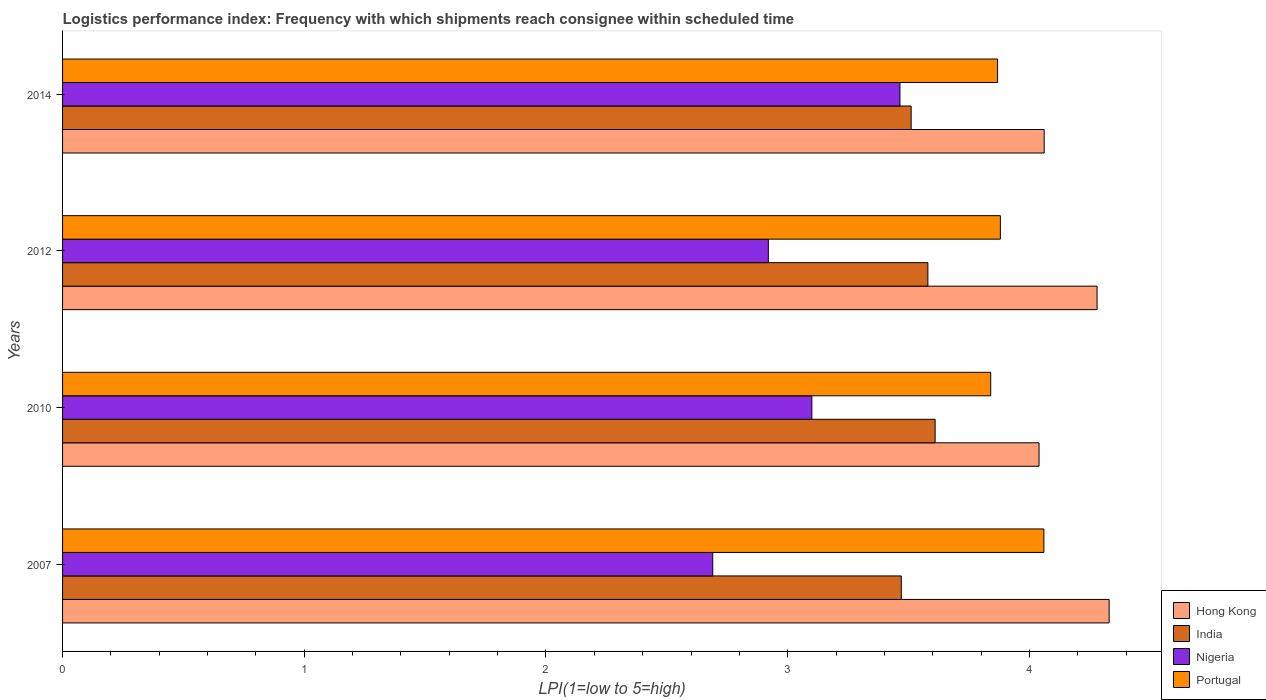How many different coloured bars are there?
Keep it short and to the point. 4. How many groups of bars are there?
Provide a succinct answer. 4. Are the number of bars per tick equal to the number of legend labels?
Provide a short and direct response. Yes. Are the number of bars on each tick of the Y-axis equal?
Give a very brief answer. Yes. How many bars are there on the 3rd tick from the bottom?
Give a very brief answer. 4. What is the label of the 3rd group of bars from the top?
Your response must be concise. 2010. What is the logistics performance index in Nigeria in 2012?
Ensure brevity in your answer.  2.92. Across all years, what is the maximum logistics performance index in India?
Your response must be concise. 3.61. Across all years, what is the minimum logistics performance index in Nigeria?
Your answer should be compact. 2.69. What is the total logistics performance index in Portugal in the graph?
Keep it short and to the point. 15.65. What is the difference between the logistics performance index in Portugal in 2007 and that in 2010?
Give a very brief answer. 0.22. What is the difference between the logistics performance index in Portugal in 2014 and the logistics performance index in Nigeria in 2012?
Provide a succinct answer. 0.95. What is the average logistics performance index in Nigeria per year?
Offer a very short reply. 3.04. In the year 2007, what is the difference between the logistics performance index in India and logistics performance index in Hong Kong?
Make the answer very short. -0.86. In how many years, is the logistics performance index in Hong Kong greater than 3 ?
Provide a succinct answer. 4. What is the ratio of the logistics performance index in India in 2007 to that in 2010?
Your answer should be compact. 0.96. What is the difference between the highest and the second highest logistics performance index in India?
Give a very brief answer. 0.03. What is the difference between the highest and the lowest logistics performance index in Nigeria?
Provide a short and direct response. 0.77. Is the sum of the logistics performance index in Portugal in 2007 and 2012 greater than the maximum logistics performance index in Nigeria across all years?
Give a very brief answer. Yes. What does the 4th bar from the top in 2012 represents?
Offer a very short reply. Hong Kong. What does the 2nd bar from the bottom in 2014 represents?
Make the answer very short. India. Is it the case that in every year, the sum of the logistics performance index in Hong Kong and logistics performance index in Portugal is greater than the logistics performance index in Nigeria?
Provide a succinct answer. Yes. How many bars are there?
Provide a short and direct response. 16. How many years are there in the graph?
Provide a succinct answer. 4. Are the values on the major ticks of X-axis written in scientific E-notation?
Ensure brevity in your answer.  No. Does the graph contain grids?
Provide a short and direct response. No. Where does the legend appear in the graph?
Ensure brevity in your answer.  Bottom right. How are the legend labels stacked?
Make the answer very short. Vertical. What is the title of the graph?
Ensure brevity in your answer.  Logistics performance index: Frequency with which shipments reach consignee within scheduled time. What is the label or title of the X-axis?
Offer a terse response. LPI(1=low to 5=high). What is the label or title of the Y-axis?
Ensure brevity in your answer.  Years. What is the LPI(1=low to 5=high) of Hong Kong in 2007?
Offer a very short reply. 4.33. What is the LPI(1=low to 5=high) in India in 2007?
Offer a very short reply. 3.47. What is the LPI(1=low to 5=high) in Nigeria in 2007?
Offer a terse response. 2.69. What is the LPI(1=low to 5=high) of Portugal in 2007?
Make the answer very short. 4.06. What is the LPI(1=low to 5=high) in Hong Kong in 2010?
Give a very brief answer. 4.04. What is the LPI(1=low to 5=high) of India in 2010?
Offer a terse response. 3.61. What is the LPI(1=low to 5=high) in Nigeria in 2010?
Your response must be concise. 3.1. What is the LPI(1=low to 5=high) of Portugal in 2010?
Provide a short and direct response. 3.84. What is the LPI(1=low to 5=high) of Hong Kong in 2012?
Offer a very short reply. 4.28. What is the LPI(1=low to 5=high) of India in 2012?
Offer a terse response. 3.58. What is the LPI(1=low to 5=high) of Nigeria in 2012?
Provide a short and direct response. 2.92. What is the LPI(1=low to 5=high) in Portugal in 2012?
Your answer should be very brief. 3.88. What is the LPI(1=low to 5=high) of Hong Kong in 2014?
Give a very brief answer. 4.06. What is the LPI(1=low to 5=high) in India in 2014?
Your answer should be compact. 3.51. What is the LPI(1=low to 5=high) in Nigeria in 2014?
Keep it short and to the point. 3.46. What is the LPI(1=low to 5=high) in Portugal in 2014?
Provide a succinct answer. 3.87. Across all years, what is the maximum LPI(1=low to 5=high) of Hong Kong?
Offer a very short reply. 4.33. Across all years, what is the maximum LPI(1=low to 5=high) of India?
Keep it short and to the point. 3.61. Across all years, what is the maximum LPI(1=low to 5=high) in Nigeria?
Your response must be concise. 3.46. Across all years, what is the maximum LPI(1=low to 5=high) of Portugal?
Keep it short and to the point. 4.06. Across all years, what is the minimum LPI(1=low to 5=high) of Hong Kong?
Your response must be concise. 4.04. Across all years, what is the minimum LPI(1=low to 5=high) in India?
Give a very brief answer. 3.47. Across all years, what is the minimum LPI(1=low to 5=high) in Nigeria?
Make the answer very short. 2.69. Across all years, what is the minimum LPI(1=low to 5=high) in Portugal?
Offer a very short reply. 3.84. What is the total LPI(1=low to 5=high) in Hong Kong in the graph?
Make the answer very short. 16.71. What is the total LPI(1=low to 5=high) in India in the graph?
Offer a terse response. 14.17. What is the total LPI(1=low to 5=high) in Nigeria in the graph?
Your answer should be very brief. 12.17. What is the total LPI(1=low to 5=high) in Portugal in the graph?
Offer a terse response. 15.65. What is the difference between the LPI(1=low to 5=high) of Hong Kong in 2007 and that in 2010?
Offer a very short reply. 0.29. What is the difference between the LPI(1=low to 5=high) of India in 2007 and that in 2010?
Ensure brevity in your answer.  -0.14. What is the difference between the LPI(1=low to 5=high) in Nigeria in 2007 and that in 2010?
Your response must be concise. -0.41. What is the difference between the LPI(1=low to 5=high) in Portugal in 2007 and that in 2010?
Your response must be concise. 0.22. What is the difference between the LPI(1=low to 5=high) of Hong Kong in 2007 and that in 2012?
Give a very brief answer. 0.05. What is the difference between the LPI(1=low to 5=high) of India in 2007 and that in 2012?
Keep it short and to the point. -0.11. What is the difference between the LPI(1=low to 5=high) of Nigeria in 2007 and that in 2012?
Keep it short and to the point. -0.23. What is the difference between the LPI(1=low to 5=high) of Portugal in 2007 and that in 2012?
Keep it short and to the point. 0.18. What is the difference between the LPI(1=low to 5=high) of Hong Kong in 2007 and that in 2014?
Your answer should be very brief. 0.27. What is the difference between the LPI(1=low to 5=high) in India in 2007 and that in 2014?
Your answer should be very brief. -0.04. What is the difference between the LPI(1=low to 5=high) of Nigeria in 2007 and that in 2014?
Provide a succinct answer. -0.77. What is the difference between the LPI(1=low to 5=high) of Portugal in 2007 and that in 2014?
Offer a very short reply. 0.19. What is the difference between the LPI(1=low to 5=high) in Hong Kong in 2010 and that in 2012?
Keep it short and to the point. -0.24. What is the difference between the LPI(1=low to 5=high) in India in 2010 and that in 2012?
Keep it short and to the point. 0.03. What is the difference between the LPI(1=low to 5=high) of Nigeria in 2010 and that in 2012?
Keep it short and to the point. 0.18. What is the difference between the LPI(1=low to 5=high) of Portugal in 2010 and that in 2012?
Provide a succinct answer. -0.04. What is the difference between the LPI(1=low to 5=high) of Hong Kong in 2010 and that in 2014?
Offer a terse response. -0.02. What is the difference between the LPI(1=low to 5=high) of India in 2010 and that in 2014?
Ensure brevity in your answer.  0.1. What is the difference between the LPI(1=low to 5=high) of Nigeria in 2010 and that in 2014?
Your answer should be compact. -0.36. What is the difference between the LPI(1=low to 5=high) of Portugal in 2010 and that in 2014?
Ensure brevity in your answer.  -0.03. What is the difference between the LPI(1=low to 5=high) of Hong Kong in 2012 and that in 2014?
Ensure brevity in your answer.  0.22. What is the difference between the LPI(1=low to 5=high) of India in 2012 and that in 2014?
Your answer should be very brief. 0.07. What is the difference between the LPI(1=low to 5=high) of Nigeria in 2012 and that in 2014?
Provide a short and direct response. -0.54. What is the difference between the LPI(1=low to 5=high) of Portugal in 2012 and that in 2014?
Ensure brevity in your answer.  0.01. What is the difference between the LPI(1=low to 5=high) of Hong Kong in 2007 and the LPI(1=low to 5=high) of India in 2010?
Your answer should be compact. 0.72. What is the difference between the LPI(1=low to 5=high) of Hong Kong in 2007 and the LPI(1=low to 5=high) of Nigeria in 2010?
Offer a terse response. 1.23. What is the difference between the LPI(1=low to 5=high) of Hong Kong in 2007 and the LPI(1=low to 5=high) of Portugal in 2010?
Your answer should be very brief. 0.49. What is the difference between the LPI(1=low to 5=high) of India in 2007 and the LPI(1=low to 5=high) of Nigeria in 2010?
Offer a very short reply. 0.37. What is the difference between the LPI(1=low to 5=high) in India in 2007 and the LPI(1=low to 5=high) in Portugal in 2010?
Offer a very short reply. -0.37. What is the difference between the LPI(1=low to 5=high) in Nigeria in 2007 and the LPI(1=low to 5=high) in Portugal in 2010?
Ensure brevity in your answer.  -1.15. What is the difference between the LPI(1=low to 5=high) in Hong Kong in 2007 and the LPI(1=low to 5=high) in Nigeria in 2012?
Offer a very short reply. 1.41. What is the difference between the LPI(1=low to 5=high) in Hong Kong in 2007 and the LPI(1=low to 5=high) in Portugal in 2012?
Provide a short and direct response. 0.45. What is the difference between the LPI(1=low to 5=high) in India in 2007 and the LPI(1=low to 5=high) in Nigeria in 2012?
Your answer should be compact. 0.55. What is the difference between the LPI(1=low to 5=high) of India in 2007 and the LPI(1=low to 5=high) of Portugal in 2012?
Offer a very short reply. -0.41. What is the difference between the LPI(1=low to 5=high) in Nigeria in 2007 and the LPI(1=low to 5=high) in Portugal in 2012?
Provide a short and direct response. -1.19. What is the difference between the LPI(1=low to 5=high) in Hong Kong in 2007 and the LPI(1=low to 5=high) in India in 2014?
Offer a terse response. 0.82. What is the difference between the LPI(1=low to 5=high) in Hong Kong in 2007 and the LPI(1=low to 5=high) in Nigeria in 2014?
Offer a very short reply. 0.87. What is the difference between the LPI(1=low to 5=high) in Hong Kong in 2007 and the LPI(1=low to 5=high) in Portugal in 2014?
Keep it short and to the point. 0.46. What is the difference between the LPI(1=low to 5=high) of India in 2007 and the LPI(1=low to 5=high) of Nigeria in 2014?
Keep it short and to the point. 0.01. What is the difference between the LPI(1=low to 5=high) in India in 2007 and the LPI(1=low to 5=high) in Portugal in 2014?
Provide a short and direct response. -0.4. What is the difference between the LPI(1=low to 5=high) of Nigeria in 2007 and the LPI(1=low to 5=high) of Portugal in 2014?
Offer a terse response. -1.18. What is the difference between the LPI(1=low to 5=high) of Hong Kong in 2010 and the LPI(1=low to 5=high) of India in 2012?
Your answer should be compact. 0.46. What is the difference between the LPI(1=low to 5=high) in Hong Kong in 2010 and the LPI(1=low to 5=high) in Nigeria in 2012?
Offer a terse response. 1.12. What is the difference between the LPI(1=low to 5=high) of Hong Kong in 2010 and the LPI(1=low to 5=high) of Portugal in 2012?
Provide a short and direct response. 0.16. What is the difference between the LPI(1=low to 5=high) of India in 2010 and the LPI(1=low to 5=high) of Nigeria in 2012?
Make the answer very short. 0.69. What is the difference between the LPI(1=low to 5=high) in India in 2010 and the LPI(1=low to 5=high) in Portugal in 2012?
Make the answer very short. -0.27. What is the difference between the LPI(1=low to 5=high) in Nigeria in 2010 and the LPI(1=low to 5=high) in Portugal in 2012?
Provide a succinct answer. -0.78. What is the difference between the LPI(1=low to 5=high) of Hong Kong in 2010 and the LPI(1=low to 5=high) of India in 2014?
Offer a terse response. 0.53. What is the difference between the LPI(1=low to 5=high) in Hong Kong in 2010 and the LPI(1=low to 5=high) in Nigeria in 2014?
Your answer should be compact. 0.58. What is the difference between the LPI(1=low to 5=high) in Hong Kong in 2010 and the LPI(1=low to 5=high) in Portugal in 2014?
Your answer should be compact. 0.17. What is the difference between the LPI(1=low to 5=high) in India in 2010 and the LPI(1=low to 5=high) in Nigeria in 2014?
Offer a very short reply. 0.15. What is the difference between the LPI(1=low to 5=high) of India in 2010 and the LPI(1=low to 5=high) of Portugal in 2014?
Your answer should be very brief. -0.26. What is the difference between the LPI(1=low to 5=high) of Nigeria in 2010 and the LPI(1=low to 5=high) of Portugal in 2014?
Offer a terse response. -0.77. What is the difference between the LPI(1=low to 5=high) in Hong Kong in 2012 and the LPI(1=low to 5=high) in India in 2014?
Your response must be concise. 0.77. What is the difference between the LPI(1=low to 5=high) of Hong Kong in 2012 and the LPI(1=low to 5=high) of Nigeria in 2014?
Ensure brevity in your answer.  0.82. What is the difference between the LPI(1=low to 5=high) in Hong Kong in 2012 and the LPI(1=low to 5=high) in Portugal in 2014?
Provide a short and direct response. 0.41. What is the difference between the LPI(1=low to 5=high) in India in 2012 and the LPI(1=low to 5=high) in Nigeria in 2014?
Provide a succinct answer. 0.12. What is the difference between the LPI(1=low to 5=high) of India in 2012 and the LPI(1=low to 5=high) of Portugal in 2014?
Offer a terse response. -0.29. What is the difference between the LPI(1=low to 5=high) in Nigeria in 2012 and the LPI(1=low to 5=high) in Portugal in 2014?
Provide a short and direct response. -0.95. What is the average LPI(1=low to 5=high) in Hong Kong per year?
Provide a short and direct response. 4.18. What is the average LPI(1=low to 5=high) of India per year?
Ensure brevity in your answer.  3.54. What is the average LPI(1=low to 5=high) in Nigeria per year?
Your answer should be very brief. 3.04. What is the average LPI(1=low to 5=high) in Portugal per year?
Ensure brevity in your answer.  3.91. In the year 2007, what is the difference between the LPI(1=low to 5=high) of Hong Kong and LPI(1=low to 5=high) of India?
Offer a very short reply. 0.86. In the year 2007, what is the difference between the LPI(1=low to 5=high) in Hong Kong and LPI(1=low to 5=high) in Nigeria?
Offer a very short reply. 1.64. In the year 2007, what is the difference between the LPI(1=low to 5=high) of Hong Kong and LPI(1=low to 5=high) of Portugal?
Your response must be concise. 0.27. In the year 2007, what is the difference between the LPI(1=low to 5=high) in India and LPI(1=low to 5=high) in Nigeria?
Your answer should be very brief. 0.78. In the year 2007, what is the difference between the LPI(1=low to 5=high) in India and LPI(1=low to 5=high) in Portugal?
Make the answer very short. -0.59. In the year 2007, what is the difference between the LPI(1=low to 5=high) in Nigeria and LPI(1=low to 5=high) in Portugal?
Your response must be concise. -1.37. In the year 2010, what is the difference between the LPI(1=low to 5=high) in Hong Kong and LPI(1=low to 5=high) in India?
Give a very brief answer. 0.43. In the year 2010, what is the difference between the LPI(1=low to 5=high) of Hong Kong and LPI(1=low to 5=high) of Nigeria?
Give a very brief answer. 0.94. In the year 2010, what is the difference between the LPI(1=low to 5=high) of Hong Kong and LPI(1=low to 5=high) of Portugal?
Provide a short and direct response. 0.2. In the year 2010, what is the difference between the LPI(1=low to 5=high) of India and LPI(1=low to 5=high) of Nigeria?
Give a very brief answer. 0.51. In the year 2010, what is the difference between the LPI(1=low to 5=high) in India and LPI(1=low to 5=high) in Portugal?
Give a very brief answer. -0.23. In the year 2010, what is the difference between the LPI(1=low to 5=high) of Nigeria and LPI(1=low to 5=high) of Portugal?
Provide a short and direct response. -0.74. In the year 2012, what is the difference between the LPI(1=low to 5=high) in Hong Kong and LPI(1=low to 5=high) in India?
Provide a succinct answer. 0.7. In the year 2012, what is the difference between the LPI(1=low to 5=high) in Hong Kong and LPI(1=low to 5=high) in Nigeria?
Make the answer very short. 1.36. In the year 2012, what is the difference between the LPI(1=low to 5=high) of Hong Kong and LPI(1=low to 5=high) of Portugal?
Keep it short and to the point. 0.4. In the year 2012, what is the difference between the LPI(1=low to 5=high) of India and LPI(1=low to 5=high) of Nigeria?
Your response must be concise. 0.66. In the year 2012, what is the difference between the LPI(1=low to 5=high) in India and LPI(1=low to 5=high) in Portugal?
Offer a terse response. -0.3. In the year 2012, what is the difference between the LPI(1=low to 5=high) of Nigeria and LPI(1=low to 5=high) of Portugal?
Provide a short and direct response. -0.96. In the year 2014, what is the difference between the LPI(1=low to 5=high) of Hong Kong and LPI(1=low to 5=high) of India?
Offer a terse response. 0.55. In the year 2014, what is the difference between the LPI(1=low to 5=high) in Hong Kong and LPI(1=low to 5=high) in Nigeria?
Your answer should be compact. 0.6. In the year 2014, what is the difference between the LPI(1=low to 5=high) of Hong Kong and LPI(1=low to 5=high) of Portugal?
Offer a very short reply. 0.19. In the year 2014, what is the difference between the LPI(1=low to 5=high) of India and LPI(1=low to 5=high) of Nigeria?
Make the answer very short. 0.05. In the year 2014, what is the difference between the LPI(1=low to 5=high) in India and LPI(1=low to 5=high) in Portugal?
Give a very brief answer. -0.36. In the year 2014, what is the difference between the LPI(1=low to 5=high) in Nigeria and LPI(1=low to 5=high) in Portugal?
Ensure brevity in your answer.  -0.4. What is the ratio of the LPI(1=low to 5=high) of Hong Kong in 2007 to that in 2010?
Ensure brevity in your answer.  1.07. What is the ratio of the LPI(1=low to 5=high) in India in 2007 to that in 2010?
Your answer should be compact. 0.96. What is the ratio of the LPI(1=low to 5=high) of Nigeria in 2007 to that in 2010?
Ensure brevity in your answer.  0.87. What is the ratio of the LPI(1=low to 5=high) of Portugal in 2007 to that in 2010?
Make the answer very short. 1.06. What is the ratio of the LPI(1=low to 5=high) in Hong Kong in 2007 to that in 2012?
Provide a succinct answer. 1.01. What is the ratio of the LPI(1=low to 5=high) in India in 2007 to that in 2012?
Offer a terse response. 0.97. What is the ratio of the LPI(1=low to 5=high) of Nigeria in 2007 to that in 2012?
Offer a very short reply. 0.92. What is the ratio of the LPI(1=low to 5=high) of Portugal in 2007 to that in 2012?
Provide a short and direct response. 1.05. What is the ratio of the LPI(1=low to 5=high) of Hong Kong in 2007 to that in 2014?
Make the answer very short. 1.07. What is the ratio of the LPI(1=low to 5=high) of India in 2007 to that in 2014?
Provide a succinct answer. 0.99. What is the ratio of the LPI(1=low to 5=high) of Nigeria in 2007 to that in 2014?
Provide a short and direct response. 0.78. What is the ratio of the LPI(1=low to 5=high) in Portugal in 2007 to that in 2014?
Provide a succinct answer. 1.05. What is the ratio of the LPI(1=low to 5=high) of Hong Kong in 2010 to that in 2012?
Your answer should be very brief. 0.94. What is the ratio of the LPI(1=low to 5=high) of India in 2010 to that in 2012?
Provide a short and direct response. 1.01. What is the ratio of the LPI(1=low to 5=high) in Nigeria in 2010 to that in 2012?
Your answer should be very brief. 1.06. What is the ratio of the LPI(1=low to 5=high) in Portugal in 2010 to that in 2012?
Give a very brief answer. 0.99. What is the ratio of the LPI(1=low to 5=high) of India in 2010 to that in 2014?
Ensure brevity in your answer.  1.03. What is the ratio of the LPI(1=low to 5=high) of Nigeria in 2010 to that in 2014?
Your answer should be compact. 0.89. What is the ratio of the LPI(1=low to 5=high) of Portugal in 2010 to that in 2014?
Provide a short and direct response. 0.99. What is the ratio of the LPI(1=low to 5=high) in Hong Kong in 2012 to that in 2014?
Offer a very short reply. 1.05. What is the ratio of the LPI(1=low to 5=high) of India in 2012 to that in 2014?
Your response must be concise. 1.02. What is the ratio of the LPI(1=low to 5=high) of Nigeria in 2012 to that in 2014?
Make the answer very short. 0.84. What is the ratio of the LPI(1=low to 5=high) in Portugal in 2012 to that in 2014?
Provide a short and direct response. 1. What is the difference between the highest and the second highest LPI(1=low to 5=high) of India?
Give a very brief answer. 0.03. What is the difference between the highest and the second highest LPI(1=low to 5=high) of Nigeria?
Your answer should be very brief. 0.36. What is the difference between the highest and the second highest LPI(1=low to 5=high) in Portugal?
Ensure brevity in your answer.  0.18. What is the difference between the highest and the lowest LPI(1=low to 5=high) in Hong Kong?
Make the answer very short. 0.29. What is the difference between the highest and the lowest LPI(1=low to 5=high) of India?
Keep it short and to the point. 0.14. What is the difference between the highest and the lowest LPI(1=low to 5=high) of Nigeria?
Give a very brief answer. 0.77. What is the difference between the highest and the lowest LPI(1=low to 5=high) in Portugal?
Your response must be concise. 0.22. 